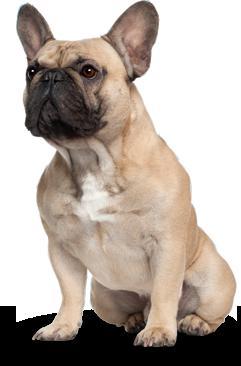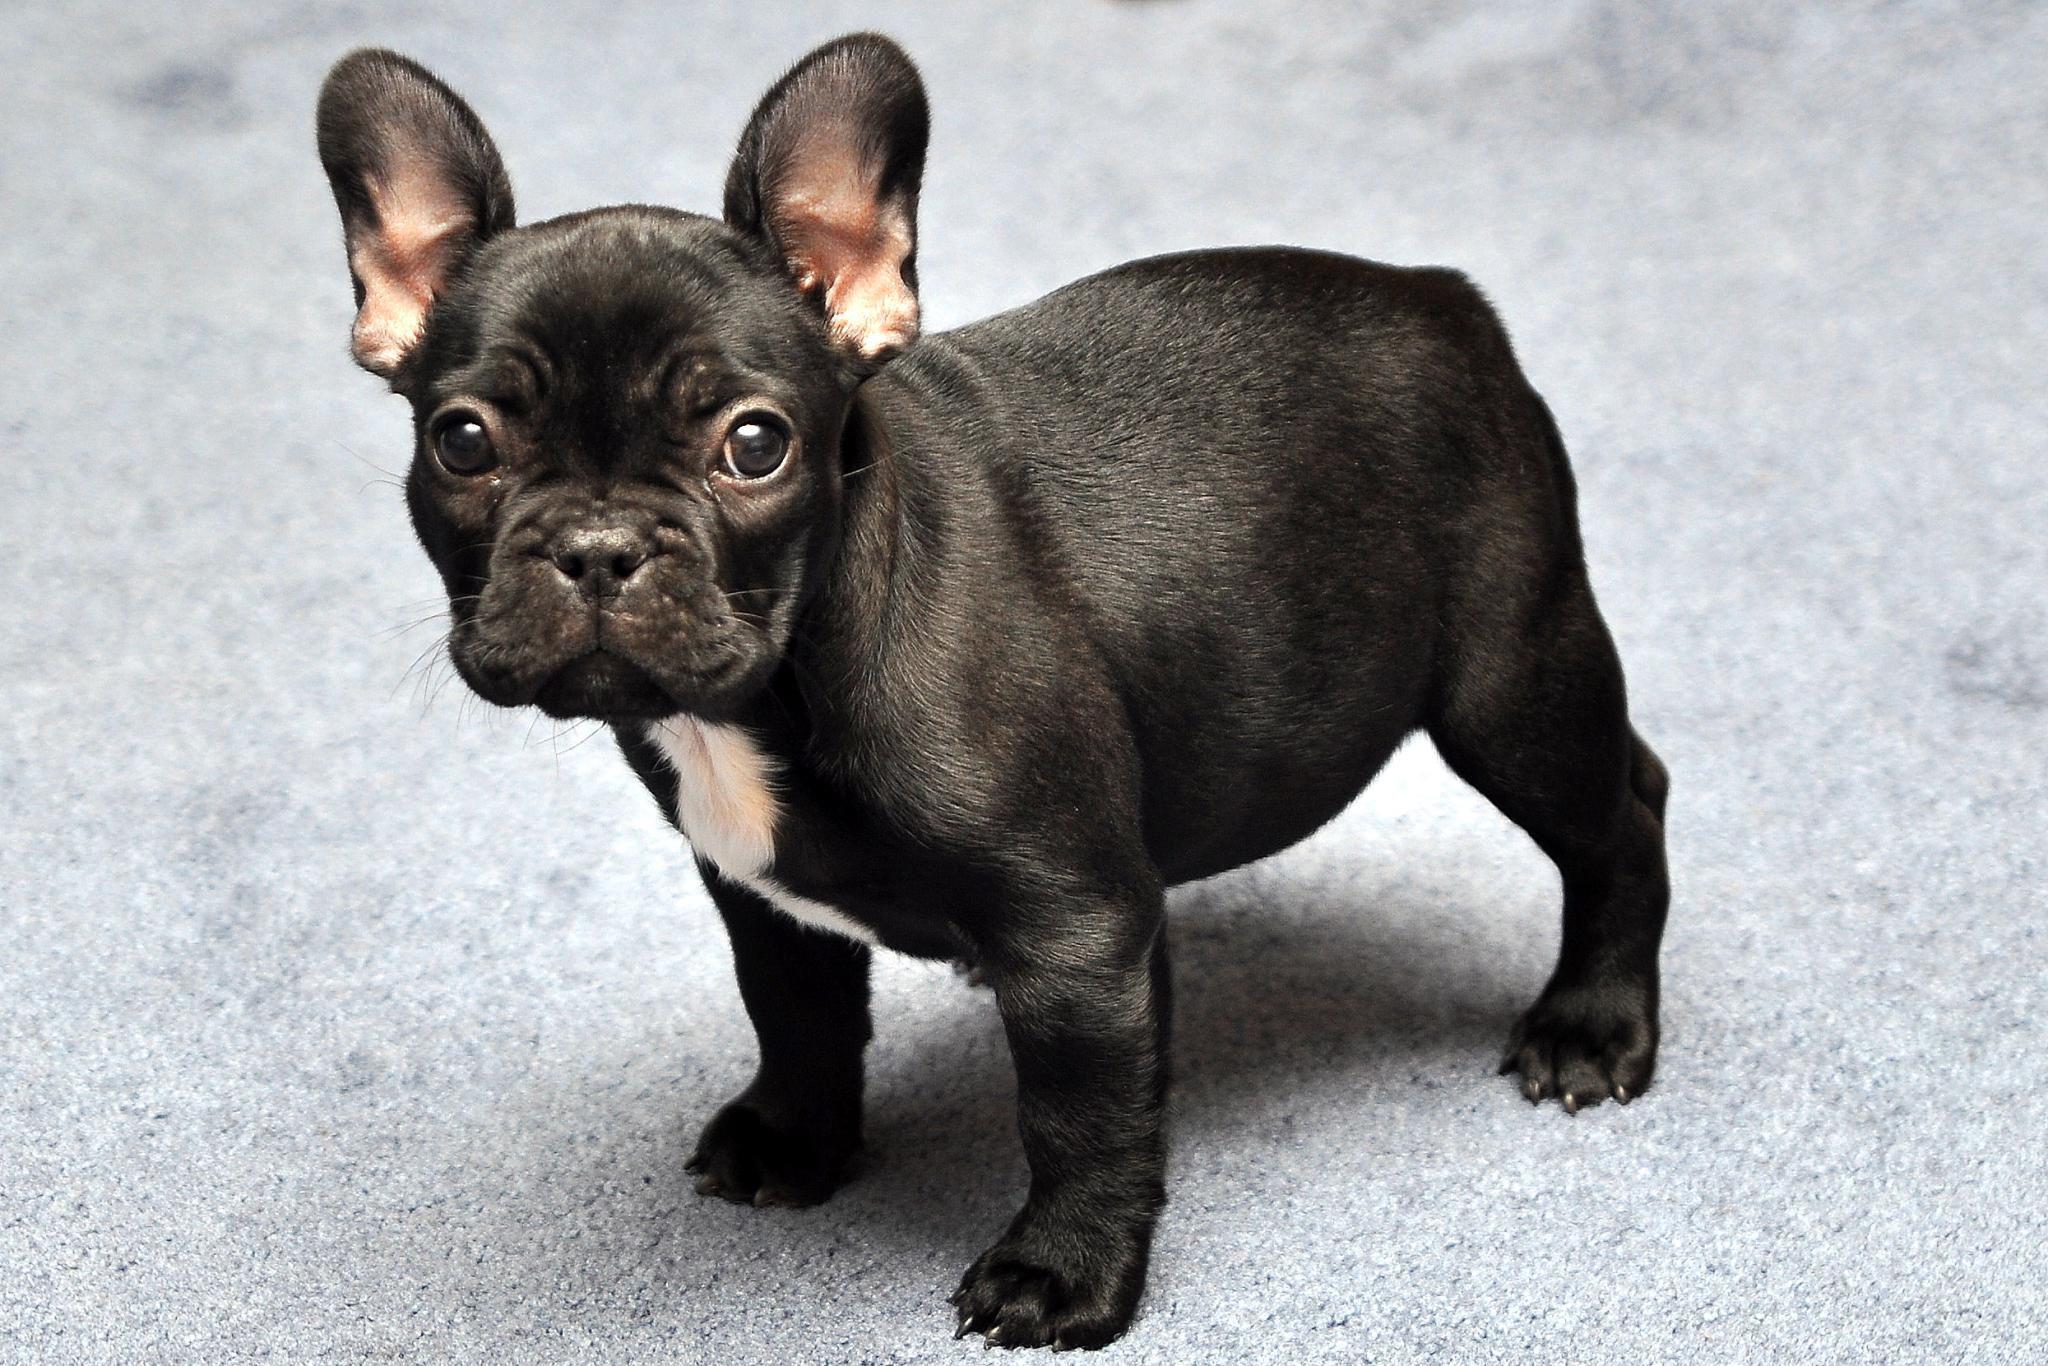The first image is the image on the left, the second image is the image on the right. Considering the images on both sides, is "The dog in the image on the right is standing on all fours." valid? Answer yes or no. Yes. The first image is the image on the left, the second image is the image on the right. For the images displayed, is the sentence "One image shows a sitting dog with pale coloring, and the other includes at least one tan dog with a dark muzzle who is wearing a collar." factually correct? Answer yes or no. No. 